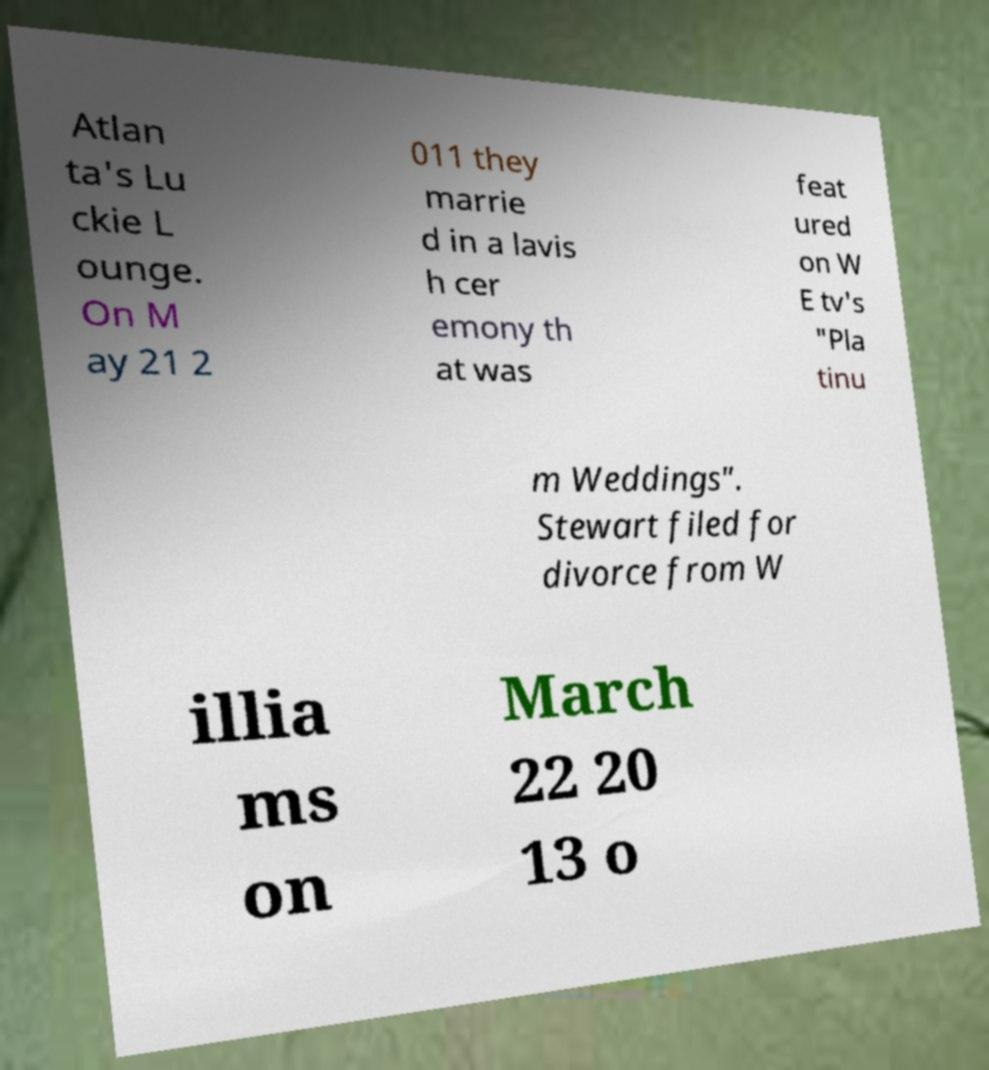Could you extract and type out the text from this image? Atlan ta's Lu ckie L ounge. On M ay 21 2 011 they marrie d in a lavis h cer emony th at was feat ured on W E tv's "Pla tinu m Weddings". Stewart filed for divorce from W illia ms on March 22 20 13 o 